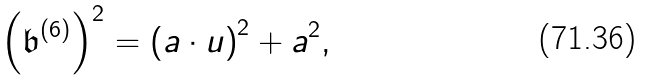Convert formula to latex. <formula><loc_0><loc_0><loc_500><loc_500>\left ( { \mathfrak b } ^ { ( 6 ) } \right ) ^ { 2 } = \left ( { a } \cdot u \right ) ^ { 2 } + { a ^ { 2 } } ,</formula> 